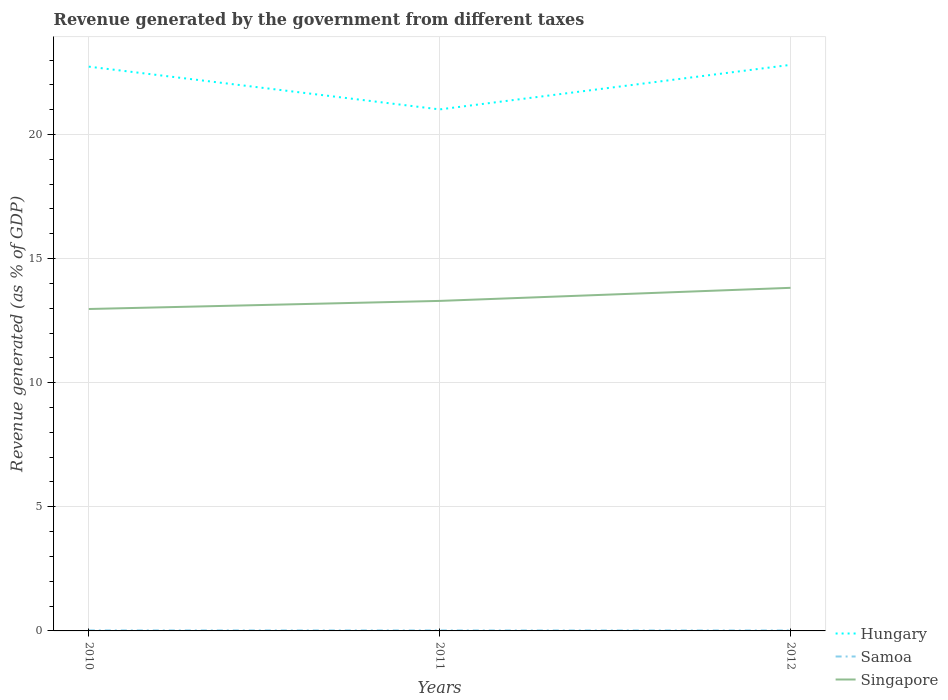Across all years, what is the maximum revenue generated by the government in Samoa?
Give a very brief answer. 0.02. What is the total revenue generated by the government in Hungary in the graph?
Ensure brevity in your answer.  -0.07. What is the difference between the highest and the second highest revenue generated by the government in Singapore?
Offer a terse response. 0.85. What is the difference between the highest and the lowest revenue generated by the government in Hungary?
Your answer should be very brief. 2. Is the revenue generated by the government in Hungary strictly greater than the revenue generated by the government in Samoa over the years?
Provide a short and direct response. No. How many lines are there?
Your answer should be very brief. 3. Are the values on the major ticks of Y-axis written in scientific E-notation?
Make the answer very short. No. Does the graph contain any zero values?
Offer a very short reply. No. Does the graph contain grids?
Your answer should be compact. Yes. Where does the legend appear in the graph?
Your answer should be compact. Bottom right. How many legend labels are there?
Offer a very short reply. 3. How are the legend labels stacked?
Your answer should be compact. Vertical. What is the title of the graph?
Give a very brief answer. Revenue generated by the government from different taxes. What is the label or title of the X-axis?
Provide a succinct answer. Years. What is the label or title of the Y-axis?
Provide a short and direct response. Revenue generated (as % of GDP). What is the Revenue generated (as % of GDP) in Hungary in 2010?
Make the answer very short. 22.73. What is the Revenue generated (as % of GDP) in Samoa in 2010?
Offer a very short reply. 0.02. What is the Revenue generated (as % of GDP) of Singapore in 2010?
Your answer should be very brief. 12.97. What is the Revenue generated (as % of GDP) of Hungary in 2011?
Your answer should be very brief. 21.01. What is the Revenue generated (as % of GDP) in Samoa in 2011?
Ensure brevity in your answer.  0.02. What is the Revenue generated (as % of GDP) of Singapore in 2011?
Ensure brevity in your answer.  13.3. What is the Revenue generated (as % of GDP) of Hungary in 2012?
Offer a terse response. 22.81. What is the Revenue generated (as % of GDP) in Samoa in 2012?
Offer a very short reply. 0.02. What is the Revenue generated (as % of GDP) of Singapore in 2012?
Keep it short and to the point. 13.82. Across all years, what is the maximum Revenue generated (as % of GDP) of Hungary?
Your response must be concise. 22.81. Across all years, what is the maximum Revenue generated (as % of GDP) in Samoa?
Provide a short and direct response. 0.02. Across all years, what is the maximum Revenue generated (as % of GDP) in Singapore?
Give a very brief answer. 13.82. Across all years, what is the minimum Revenue generated (as % of GDP) of Hungary?
Your response must be concise. 21.01. Across all years, what is the minimum Revenue generated (as % of GDP) of Samoa?
Your answer should be compact. 0.02. Across all years, what is the minimum Revenue generated (as % of GDP) in Singapore?
Your answer should be very brief. 12.97. What is the total Revenue generated (as % of GDP) in Hungary in the graph?
Your answer should be very brief. 66.55. What is the total Revenue generated (as % of GDP) in Samoa in the graph?
Your answer should be compact. 0.06. What is the total Revenue generated (as % of GDP) of Singapore in the graph?
Ensure brevity in your answer.  40.09. What is the difference between the Revenue generated (as % of GDP) in Hungary in 2010 and that in 2011?
Give a very brief answer. 1.72. What is the difference between the Revenue generated (as % of GDP) of Samoa in 2010 and that in 2011?
Make the answer very short. 0. What is the difference between the Revenue generated (as % of GDP) in Singapore in 2010 and that in 2011?
Ensure brevity in your answer.  -0.33. What is the difference between the Revenue generated (as % of GDP) of Hungary in 2010 and that in 2012?
Keep it short and to the point. -0.07. What is the difference between the Revenue generated (as % of GDP) in Samoa in 2010 and that in 2012?
Offer a terse response. 0. What is the difference between the Revenue generated (as % of GDP) in Singapore in 2010 and that in 2012?
Your response must be concise. -0.85. What is the difference between the Revenue generated (as % of GDP) of Hungary in 2011 and that in 2012?
Your response must be concise. -1.79. What is the difference between the Revenue generated (as % of GDP) in Samoa in 2011 and that in 2012?
Your response must be concise. 0. What is the difference between the Revenue generated (as % of GDP) of Singapore in 2011 and that in 2012?
Offer a very short reply. -0.53. What is the difference between the Revenue generated (as % of GDP) in Hungary in 2010 and the Revenue generated (as % of GDP) in Samoa in 2011?
Keep it short and to the point. 22.71. What is the difference between the Revenue generated (as % of GDP) of Hungary in 2010 and the Revenue generated (as % of GDP) of Singapore in 2011?
Your answer should be very brief. 9.44. What is the difference between the Revenue generated (as % of GDP) in Samoa in 2010 and the Revenue generated (as % of GDP) in Singapore in 2011?
Offer a very short reply. -13.27. What is the difference between the Revenue generated (as % of GDP) of Hungary in 2010 and the Revenue generated (as % of GDP) of Samoa in 2012?
Offer a terse response. 22.71. What is the difference between the Revenue generated (as % of GDP) of Hungary in 2010 and the Revenue generated (as % of GDP) of Singapore in 2012?
Ensure brevity in your answer.  8.91. What is the difference between the Revenue generated (as % of GDP) in Samoa in 2010 and the Revenue generated (as % of GDP) in Singapore in 2012?
Make the answer very short. -13.8. What is the difference between the Revenue generated (as % of GDP) of Hungary in 2011 and the Revenue generated (as % of GDP) of Samoa in 2012?
Offer a terse response. 20.99. What is the difference between the Revenue generated (as % of GDP) in Hungary in 2011 and the Revenue generated (as % of GDP) in Singapore in 2012?
Offer a very short reply. 7.19. What is the difference between the Revenue generated (as % of GDP) of Samoa in 2011 and the Revenue generated (as % of GDP) of Singapore in 2012?
Make the answer very short. -13.8. What is the average Revenue generated (as % of GDP) of Hungary per year?
Your response must be concise. 22.18. What is the average Revenue generated (as % of GDP) of Samoa per year?
Provide a short and direct response. 0.02. What is the average Revenue generated (as % of GDP) of Singapore per year?
Give a very brief answer. 13.36. In the year 2010, what is the difference between the Revenue generated (as % of GDP) in Hungary and Revenue generated (as % of GDP) in Samoa?
Offer a terse response. 22.71. In the year 2010, what is the difference between the Revenue generated (as % of GDP) of Hungary and Revenue generated (as % of GDP) of Singapore?
Provide a succinct answer. 9.76. In the year 2010, what is the difference between the Revenue generated (as % of GDP) in Samoa and Revenue generated (as % of GDP) in Singapore?
Provide a short and direct response. -12.95. In the year 2011, what is the difference between the Revenue generated (as % of GDP) in Hungary and Revenue generated (as % of GDP) in Samoa?
Your answer should be very brief. 20.99. In the year 2011, what is the difference between the Revenue generated (as % of GDP) of Hungary and Revenue generated (as % of GDP) of Singapore?
Keep it short and to the point. 7.71. In the year 2011, what is the difference between the Revenue generated (as % of GDP) in Samoa and Revenue generated (as % of GDP) in Singapore?
Ensure brevity in your answer.  -13.28. In the year 2012, what is the difference between the Revenue generated (as % of GDP) in Hungary and Revenue generated (as % of GDP) in Samoa?
Your response must be concise. 22.79. In the year 2012, what is the difference between the Revenue generated (as % of GDP) in Hungary and Revenue generated (as % of GDP) in Singapore?
Your answer should be compact. 8.98. In the year 2012, what is the difference between the Revenue generated (as % of GDP) of Samoa and Revenue generated (as % of GDP) of Singapore?
Your response must be concise. -13.8. What is the ratio of the Revenue generated (as % of GDP) in Hungary in 2010 to that in 2011?
Provide a succinct answer. 1.08. What is the ratio of the Revenue generated (as % of GDP) of Samoa in 2010 to that in 2011?
Offer a very short reply. 1.06. What is the ratio of the Revenue generated (as % of GDP) of Singapore in 2010 to that in 2011?
Provide a short and direct response. 0.98. What is the ratio of the Revenue generated (as % of GDP) in Hungary in 2010 to that in 2012?
Offer a very short reply. 1. What is the ratio of the Revenue generated (as % of GDP) in Samoa in 2010 to that in 2012?
Make the answer very short. 1.11. What is the ratio of the Revenue generated (as % of GDP) of Singapore in 2010 to that in 2012?
Your answer should be compact. 0.94. What is the ratio of the Revenue generated (as % of GDP) of Hungary in 2011 to that in 2012?
Ensure brevity in your answer.  0.92. What is the ratio of the Revenue generated (as % of GDP) in Samoa in 2011 to that in 2012?
Provide a short and direct response. 1.05. What is the ratio of the Revenue generated (as % of GDP) in Singapore in 2011 to that in 2012?
Offer a very short reply. 0.96. What is the difference between the highest and the second highest Revenue generated (as % of GDP) in Hungary?
Ensure brevity in your answer.  0.07. What is the difference between the highest and the second highest Revenue generated (as % of GDP) of Samoa?
Make the answer very short. 0. What is the difference between the highest and the second highest Revenue generated (as % of GDP) in Singapore?
Your response must be concise. 0.53. What is the difference between the highest and the lowest Revenue generated (as % of GDP) of Hungary?
Make the answer very short. 1.79. What is the difference between the highest and the lowest Revenue generated (as % of GDP) of Samoa?
Offer a very short reply. 0. What is the difference between the highest and the lowest Revenue generated (as % of GDP) of Singapore?
Offer a terse response. 0.85. 